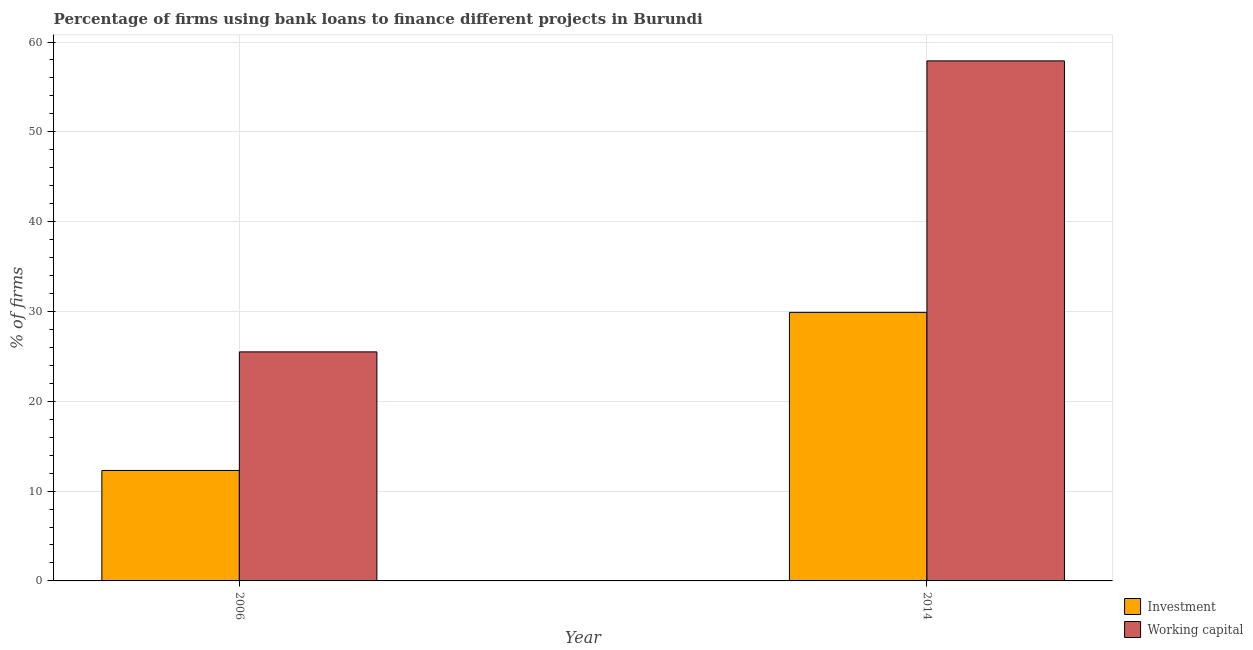Are the number of bars on each tick of the X-axis equal?
Your response must be concise. Yes. How many bars are there on the 2nd tick from the right?
Your answer should be very brief. 2. Across all years, what is the maximum percentage of firms using banks to finance investment?
Your answer should be very brief. 29.9. In which year was the percentage of firms using banks to finance investment maximum?
Offer a very short reply. 2014. In which year was the percentage of firms using banks to finance working capital minimum?
Keep it short and to the point. 2006. What is the total percentage of firms using banks to finance investment in the graph?
Your response must be concise. 42.2. What is the difference between the percentage of firms using banks to finance working capital in 2006 and that in 2014?
Your response must be concise. -32.4. What is the difference between the percentage of firms using banks to finance working capital in 2014 and the percentage of firms using banks to finance investment in 2006?
Your response must be concise. 32.4. What is the average percentage of firms using banks to finance investment per year?
Keep it short and to the point. 21.1. What is the ratio of the percentage of firms using banks to finance investment in 2006 to that in 2014?
Offer a very short reply. 0.41. Is the percentage of firms using banks to finance working capital in 2006 less than that in 2014?
Your answer should be very brief. Yes. What does the 1st bar from the left in 2006 represents?
Give a very brief answer. Investment. What does the 2nd bar from the right in 2006 represents?
Provide a succinct answer. Investment. How many bars are there?
Offer a very short reply. 4. What is the difference between two consecutive major ticks on the Y-axis?
Give a very brief answer. 10. Are the values on the major ticks of Y-axis written in scientific E-notation?
Your response must be concise. No. Does the graph contain any zero values?
Provide a succinct answer. No. How many legend labels are there?
Provide a short and direct response. 2. What is the title of the graph?
Your answer should be compact. Percentage of firms using bank loans to finance different projects in Burundi. Does "Stunting" appear as one of the legend labels in the graph?
Provide a short and direct response. No. What is the label or title of the X-axis?
Your answer should be compact. Year. What is the label or title of the Y-axis?
Your answer should be compact. % of firms. What is the % of firms in Investment in 2006?
Offer a very short reply. 12.3. What is the % of firms in Investment in 2014?
Provide a short and direct response. 29.9. What is the % of firms in Working capital in 2014?
Provide a short and direct response. 57.9. Across all years, what is the maximum % of firms in Investment?
Ensure brevity in your answer.  29.9. Across all years, what is the maximum % of firms of Working capital?
Ensure brevity in your answer.  57.9. Across all years, what is the minimum % of firms in Working capital?
Offer a terse response. 25.5. What is the total % of firms of Investment in the graph?
Provide a short and direct response. 42.2. What is the total % of firms in Working capital in the graph?
Make the answer very short. 83.4. What is the difference between the % of firms in Investment in 2006 and that in 2014?
Make the answer very short. -17.6. What is the difference between the % of firms of Working capital in 2006 and that in 2014?
Offer a terse response. -32.4. What is the difference between the % of firms of Investment in 2006 and the % of firms of Working capital in 2014?
Provide a succinct answer. -45.6. What is the average % of firms in Investment per year?
Ensure brevity in your answer.  21.1. What is the average % of firms of Working capital per year?
Provide a succinct answer. 41.7. In the year 2014, what is the difference between the % of firms in Investment and % of firms in Working capital?
Offer a very short reply. -28. What is the ratio of the % of firms of Investment in 2006 to that in 2014?
Offer a very short reply. 0.41. What is the ratio of the % of firms in Working capital in 2006 to that in 2014?
Offer a terse response. 0.44. What is the difference between the highest and the second highest % of firms of Working capital?
Your answer should be very brief. 32.4. What is the difference between the highest and the lowest % of firms of Investment?
Your answer should be very brief. 17.6. What is the difference between the highest and the lowest % of firms of Working capital?
Keep it short and to the point. 32.4. 